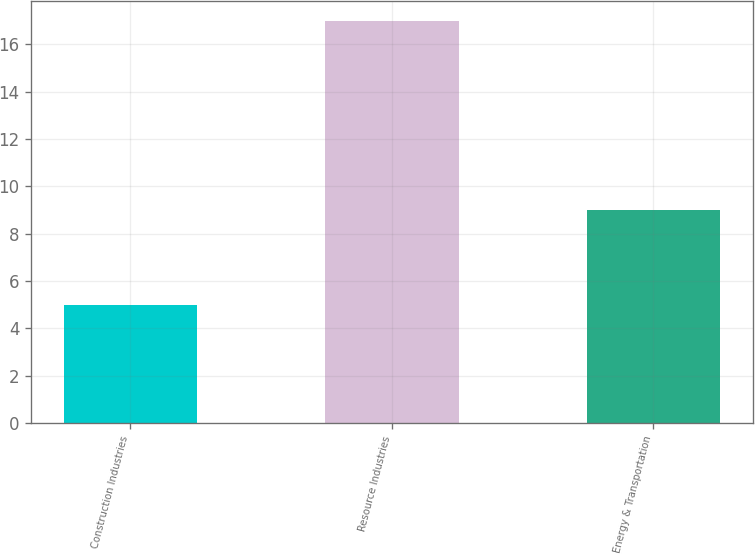Convert chart. <chart><loc_0><loc_0><loc_500><loc_500><bar_chart><fcel>Construction Industries<fcel>Resource Industries<fcel>Energy & Transportation<nl><fcel>5<fcel>17<fcel>9<nl></chart> 